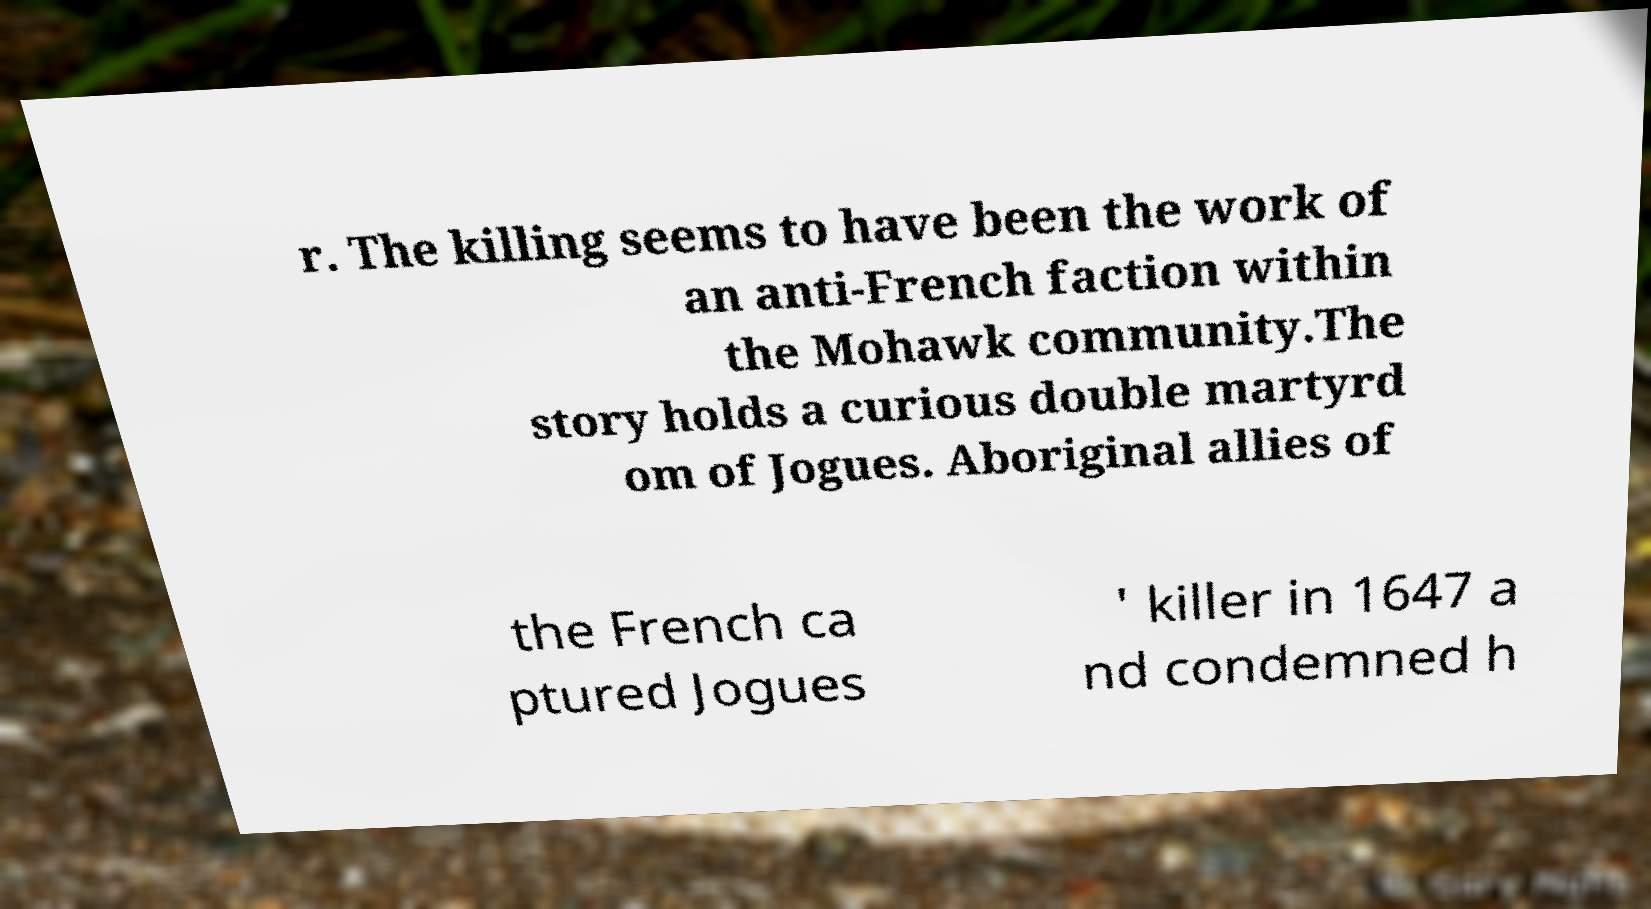Can you read and provide the text displayed in the image?This photo seems to have some interesting text. Can you extract and type it out for me? r. The killing seems to have been the work of an anti-French faction within the Mohawk community.The story holds a curious double martyrd om of Jogues. Aboriginal allies of the French ca ptured Jogues ' killer in 1647 a nd condemned h 